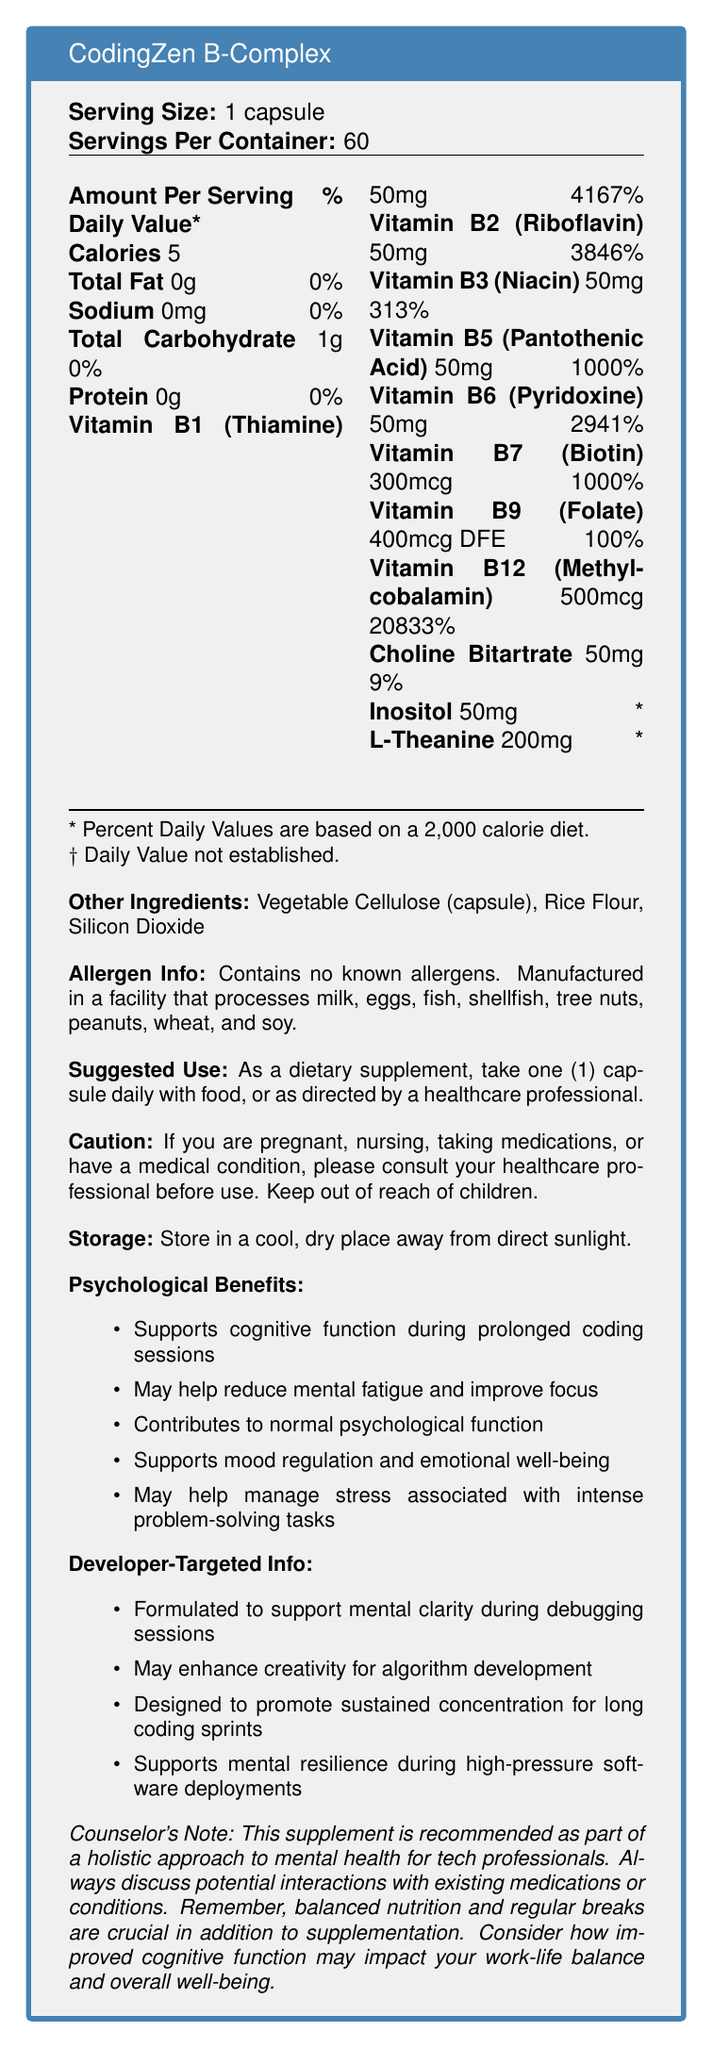what is the serving size of CodingZen B-Complex? The serving size is stated in the document as "Serving Size: 1 capsule".
Answer: 1 capsule how many servings are there per container? The document mentions that there are 60 servings per container.
Answer: 60 servings how many calories does each serving contain? The document lists the calorie content per serving as 5.
Answer: 5 calories what is the daily value percentage of Vitamin B12 in one serving? The daily value percentage for Vitamin B12 is specified as 20833%.
Answer: 20833% which two ingredients contribute to Vitamin B7 (Biotin)? A. Pantothenic Acid and Inositol B. Biotin and Folate C. Thiamine and Biotin D. Biotin and Choline Bitartrate The two ingredients that contribute are listed as Biotin (Vitamin B7) and Choline Bitartrate.
Answer: D how much L-Theanine is included per serving? The amount of L-Theanine per serving is listed as 200mg.
Answer: 200mg is this vitamin supplement free of allergens? The document states that the product contains no known allergens.
Answer: Yes which ingredient has the highest daily value percentage per serving? A. Vitamin B1 Thiamine B. Vitamin B2 Riboflavin C. Vitamin B3 Niacin D. Vitamin B12 Methylcobalamin Vitamin B12 Methylcobalamin has the highest daily value percentage at 20833%.
Answer: D what is the recommended use for this supplement? The document states this as the suggested use.
Answer: As a dietary supplement, take one (1) capsule daily with food, or as directed by a healthcare professional. who should be consulted before taking this supplement if you have a medical condition? The document advises consulting a healthcare professional before use if you have a medical condition.
Answer: Healthcare professional what conditions are mentioned in the caution statement regarding use of the product? The caution advises those who are pregnant, nursing, taking medications, or have a medical condition to consult a healthcare professional before use.
Answer: Pregnancy, nursing, medications, or medical condition summarize the overall content of the document The document provides detailed information about the nutritional content, instructions for use, potential psychological benefits, and safety warnings for the CodingZen B-Complex supplement.
Answer: The document provides the nutrition facts for CodingZen B-Complex, a dietary supplement aimed at supporting mental clarity and emotional well-being during intense coding sessions. It includes information on serving size, ingredient amounts and daily values, suggested usage, cautionary notes, and psychological benefits. what are the primary psychological benefits mentioned in the document? The psychological benefits include supporting cognitive function, reducing mental fatigue, improving focus, supporting mood regulation, and managing stress.
Answer: Supports cognitive function, reduces mental fatigue, improves focus, supports mood regulation, helps manage stress which vitamins in the supplement have more than 3000% of the daily value per serving? These vitamins have daily value percentages greater than 3000%.
Answer: Vitamin B1 Thiamine, Vitamin B2 Riboflavin, Vitamin B6 Pyridoxine, Vitamin B12 Methylcobalamin how does this supplement aim to benefit developers during high-pressure software deployments? The document mentions that the supplement supports mental resilience during high-pressure software deployments.
Answer: Supports mental resilience what are the other ingredients listed in this supplement? The other ingredients listed are Vegetable Cellulose (capsule), Rice Flour, and Silicon Dioxide.
Answer: Vegetable Cellulose (capsule), Rice Flour, Silicon Dioxide can we find the exact amount of calories each type of Vitamin B contributes to the serving size? The document does not provide detailed caloric information per individual vitamin.
Answer: Cannot be determined 